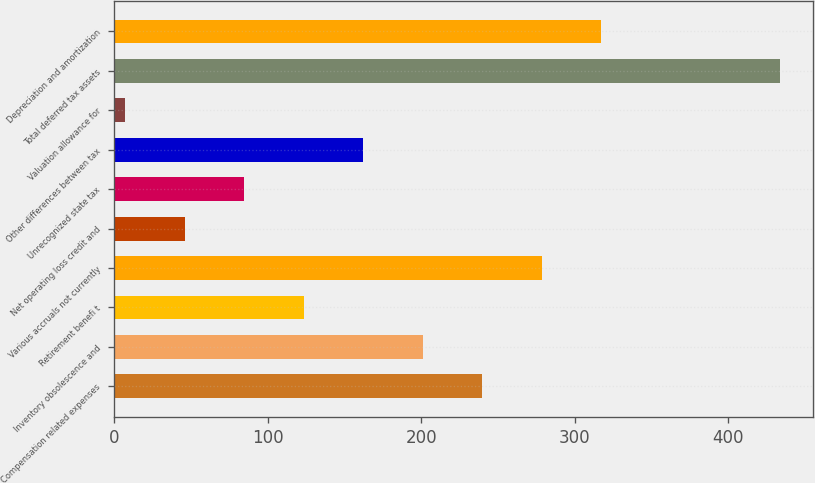Convert chart. <chart><loc_0><loc_0><loc_500><loc_500><bar_chart><fcel>Compensation related expenses<fcel>Inventory obsolescence and<fcel>Retirement benefi t<fcel>Various accruals not currently<fcel>Net operating loss credit and<fcel>Unrecognized state tax<fcel>Other differences between tax<fcel>Valuation allowance for<fcel>Total deferred tax assets<fcel>Depreciation and amortization<nl><fcel>239.64<fcel>200.9<fcel>123.42<fcel>278.38<fcel>45.94<fcel>84.68<fcel>162.16<fcel>7.2<fcel>433.34<fcel>317.12<nl></chart> 